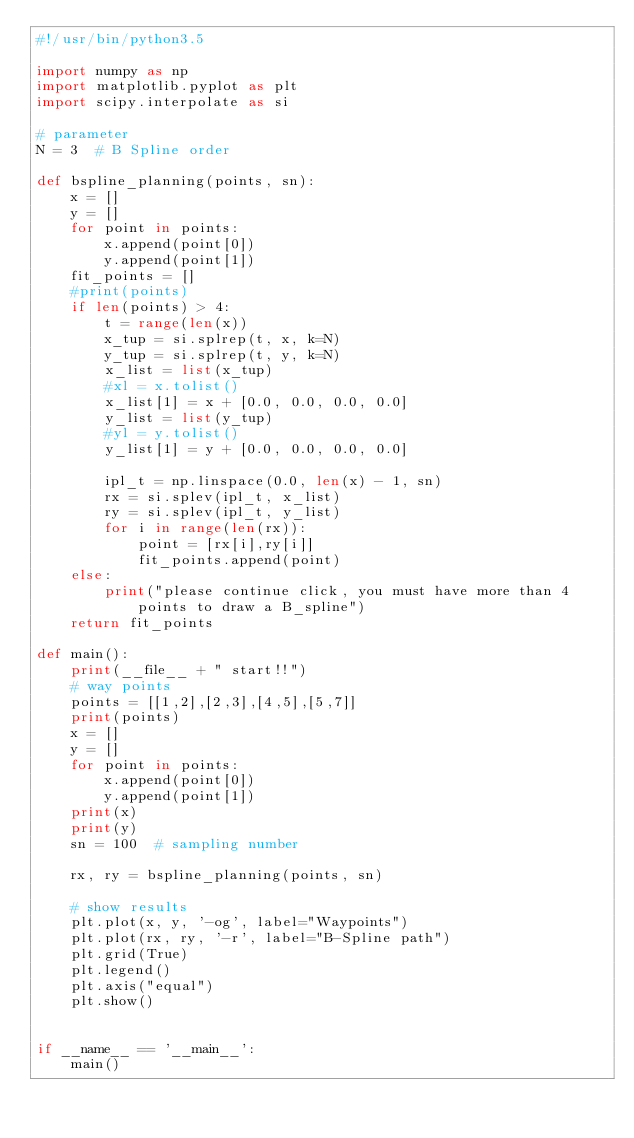Convert code to text. <code><loc_0><loc_0><loc_500><loc_500><_Python_>#!/usr/bin/python3.5

import numpy as np
import matplotlib.pyplot as plt
import scipy.interpolate as si

# parameter
N = 3  # B Spline order

def bspline_planning(points, sn):
    x = []
    y = []
    for point in points:
        x.append(point[0])
        y.append(point[1])
    fit_points = []
    #print(points)
    if len(points) > 4:
        t = range(len(x))
        x_tup = si.splrep(t, x, k=N)
        y_tup = si.splrep(t, y, k=N)
        x_list = list(x_tup)
        #xl = x.tolist()
        x_list[1] = x + [0.0, 0.0, 0.0, 0.0]
        y_list = list(y_tup)
        #yl = y.tolist()
        y_list[1] = y + [0.0, 0.0, 0.0, 0.0]

        ipl_t = np.linspace(0.0, len(x) - 1, sn)
        rx = si.splev(ipl_t, x_list)
        ry = si.splev(ipl_t, y_list)
        for i in range(len(rx)):
            point = [rx[i],ry[i]]
            fit_points.append(point)
    else:
        print("please continue click, you must have more than 4 points to draw a B_spline")
    return fit_points

def main():
    print(__file__ + " start!!")
    # way points
    points = [[1,2],[2,3],[4,5],[5,7]]
    print(points)
    x = []
    y = []
    for point in points:
        x.append(point[0])
        y.append(point[1])
    print(x)
    print(y)
    sn = 100  # sampling number

    rx, ry = bspline_planning(points, sn)

    # show results
    plt.plot(x, y, '-og', label="Waypoints")
    plt.plot(rx, ry, '-r', label="B-Spline path")
    plt.grid(True)
    plt.legend()
    plt.axis("equal")
    plt.show()


if __name__ == '__main__':
    main()
</code> 